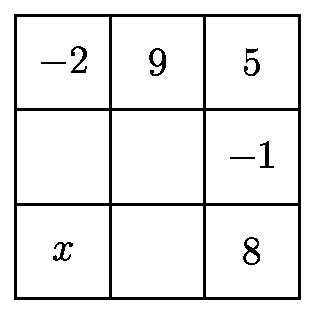The grid below is to be filled with integers in such a way that the sum of the numbers in each row and the sum of the numbers in each column are the same. Four numbers are missing. The number $x$ in the lower left corner is larger than the other three missing numbers. What is the smallest possible value of $x$? To solve such a puzzle, one usually calculates the sums of the rows and columns using the provided numbers, then applies logic and arithmetic skills to deduce the missing values while ensuring the sums are consistent across all rows and columns. The smallest possible value for $x$ is identified when the other missing numbers are determined, making $x$ the largest among them while maintaining the consistent sum condition. 